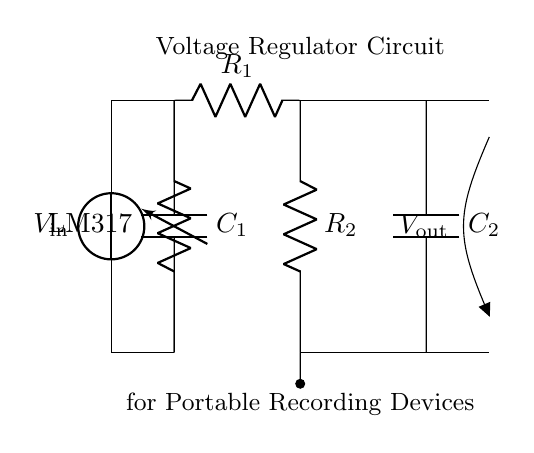What is the input voltage of this circuit? The input voltage is represented as V_in at the source on the left side of the circuit diagram.
Answer: V_in What type of voltage regulator is used? The voltage regulator in this circuit is labeled as LM317, which is a common adjustable voltage regulator.
Answer: LM317 What are the two resistors in the circuit? The two resistors are labeled as R_1 and R_2, and they are positioned in a specific configuration following the voltage regulator.
Answer: R_1 and R_2 Which component stabilizes the voltage output? The LM317 voltage regulator stabilizes the voltage output by adjusting the voltage according to the resistor values and the input voltage.
Answer: LM317 What is the purpose of capacitors in this circuit? Capacitors C_1 and C_2 are used to filter out noise and stabilize the voltage levels, ensuring smooth operation of connected devices.
Answer: Filter and stabilize How is the output voltage represented in the diagram? The output voltage is indicated at the right side of the circuit, labeled as V_out, connecting the outputs from R_2 to the load.
Answer: V_out What is the role of the ground symbol in the circuit? The ground symbol indicates the reference point in the circuit, providing a common return path for current and establishing a zero-voltage reference level.
Answer: Reference point 